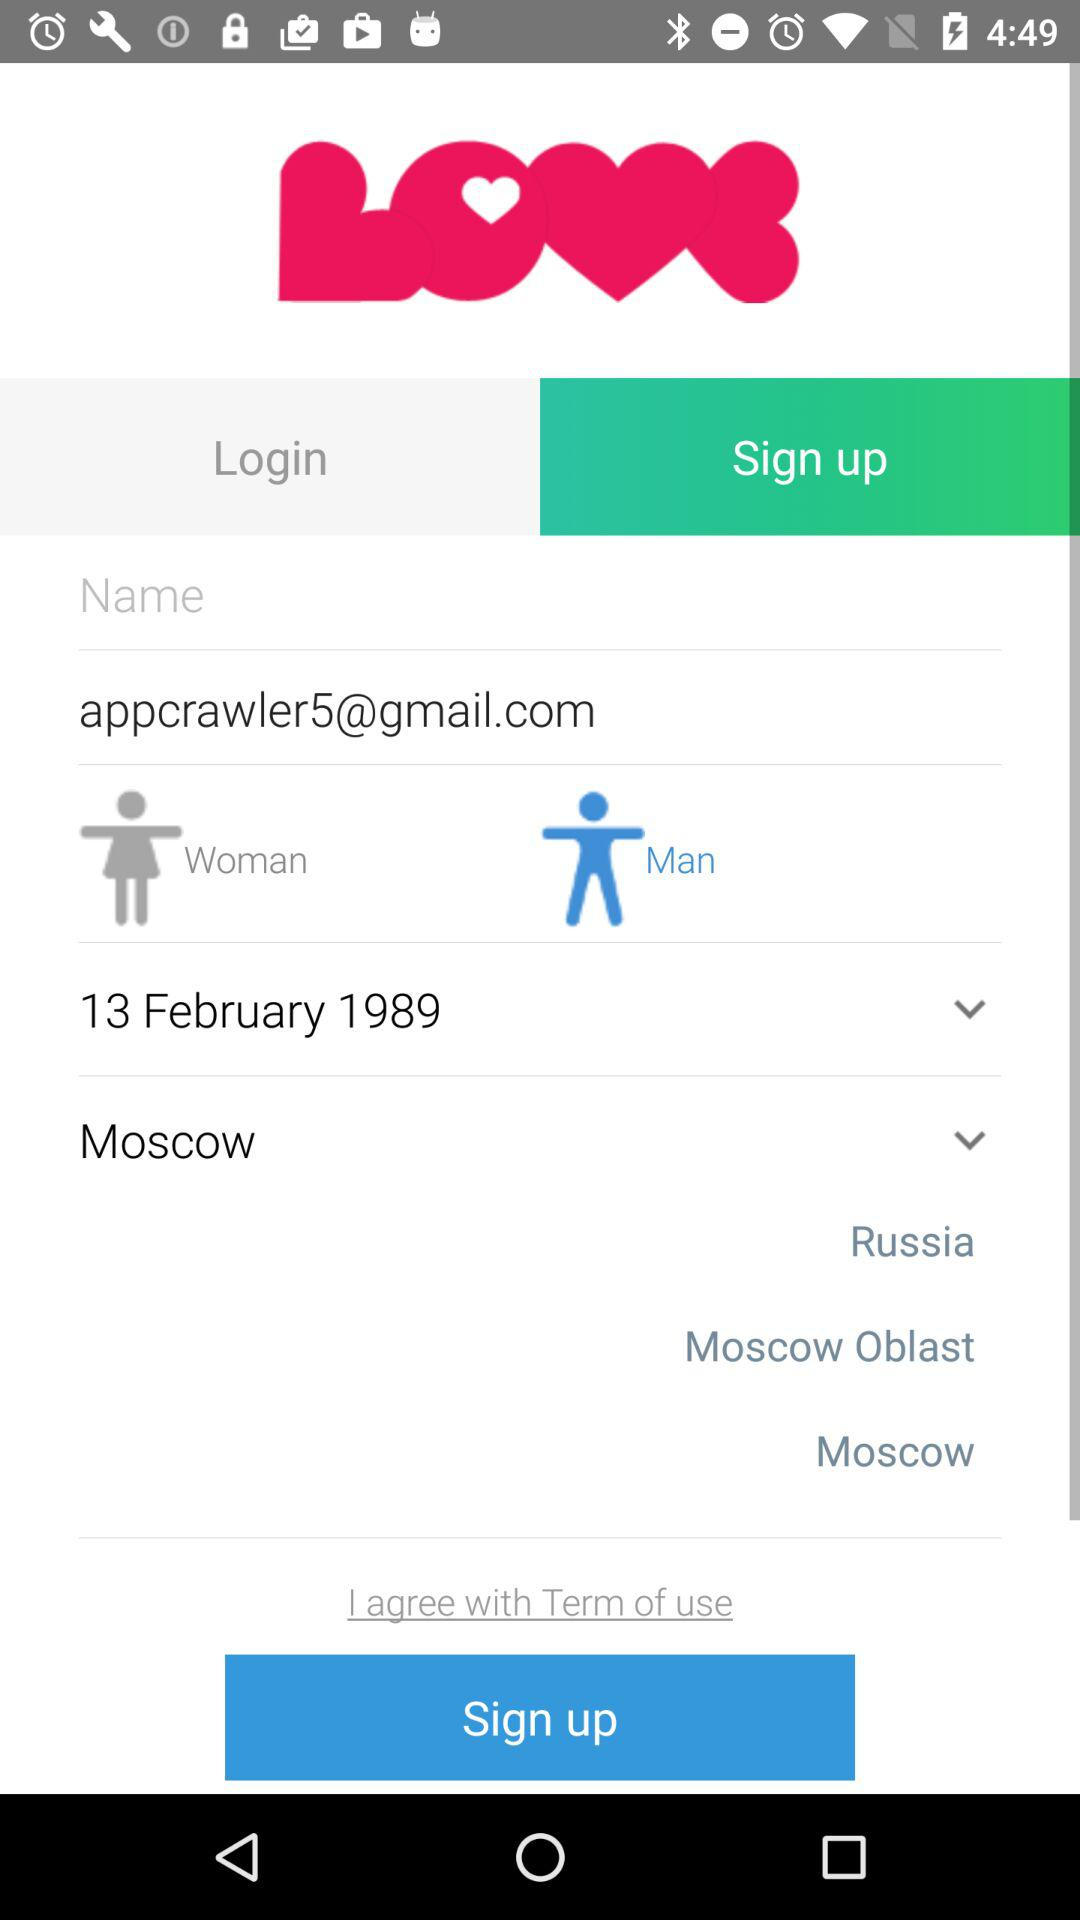Which location is selected? The selected location is Moscow. 